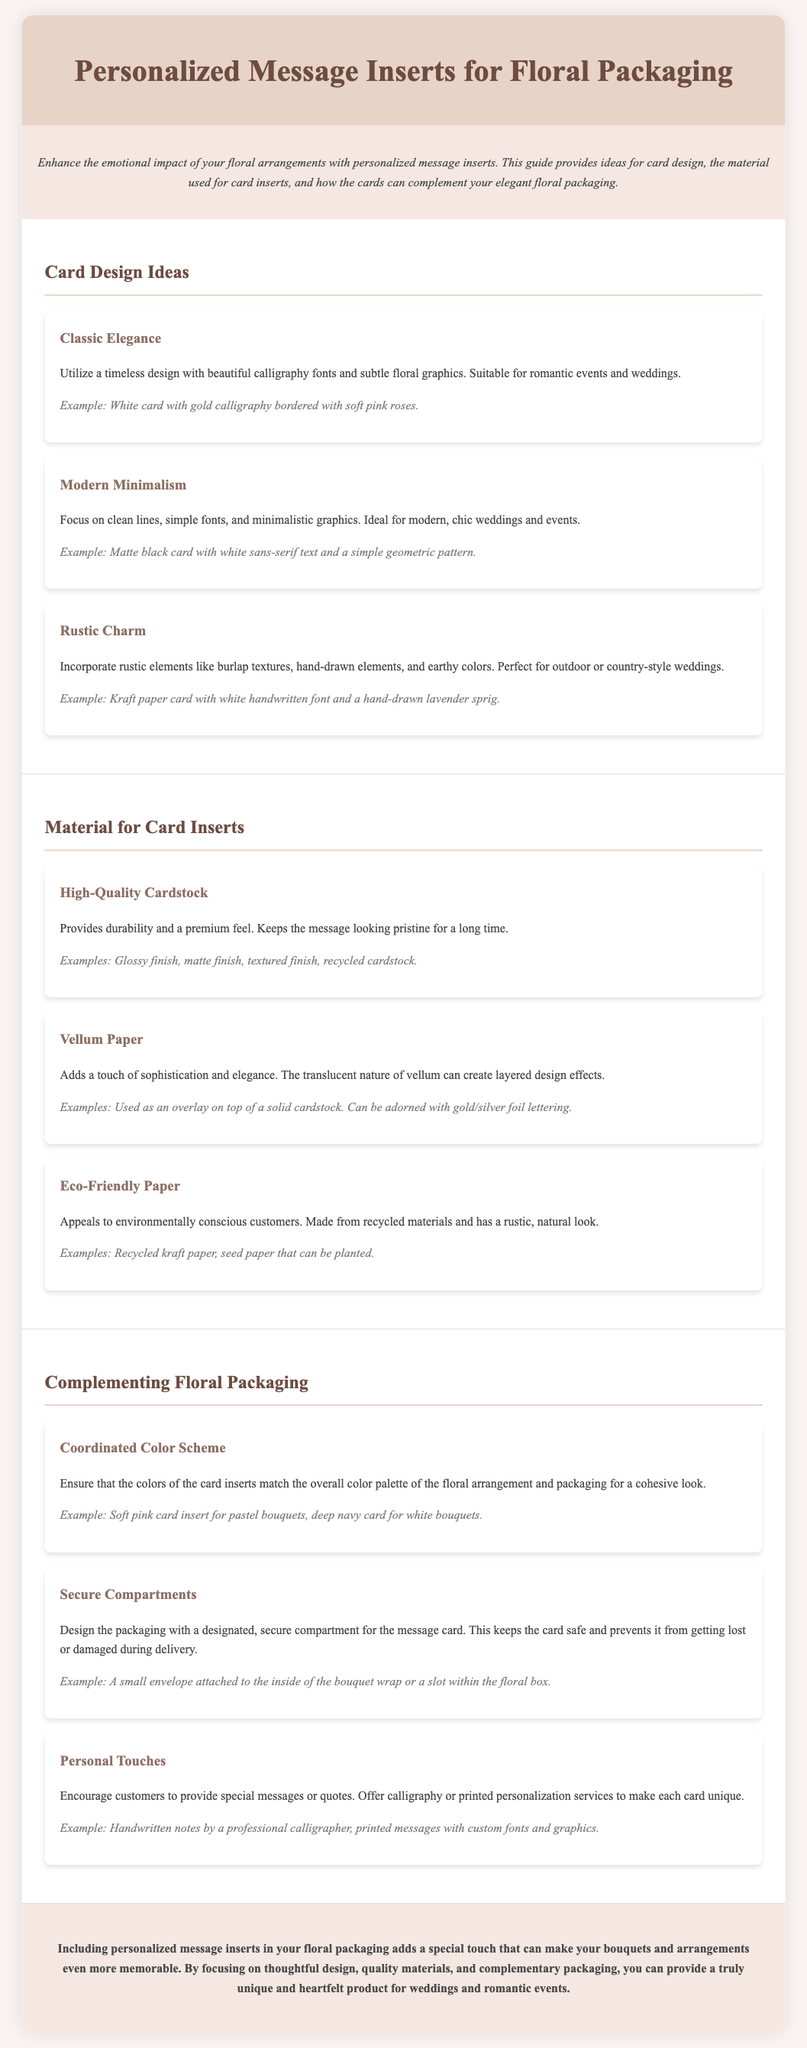What is the title of the document? The title of the document is stated in the header section.
Answer: Personalized Message Inserts for Floral Packaging How many card design ideas are mentioned? The section on card design ideas lists three distinct options.
Answer: Three What material is suggested for high-quality card inserts? This material is highlighted in the document as providing durability and a premium feel.
Answer: High-Quality Cardstock What is the example given for rustic charm card design? The document explicitly provides an example to illustrate the rustic charm design style.
Answer: Kraft paper card with white handwritten font and a hand-drawn lavender sprig What is a recommended feature for secure message card storage? This feature is outlined in the section discussing how to complement floral packaging.
Answer: Secure Compartments How does the document suggest adding a personal touch to message cards? The document describes a method to encourage personalization of the cards.
Answer: Handwritten notes by a professional calligrapher Which color card insert is suggested for pastel bouquets? The document specifies a certain color that should match the overall color palette for these bouquets.
Answer: Soft pink What type of paper appeals to environmentally conscious customers? This material is highlighted as appealing to a specific customer base within the document.
Answer: Eco-Friendly Paper 